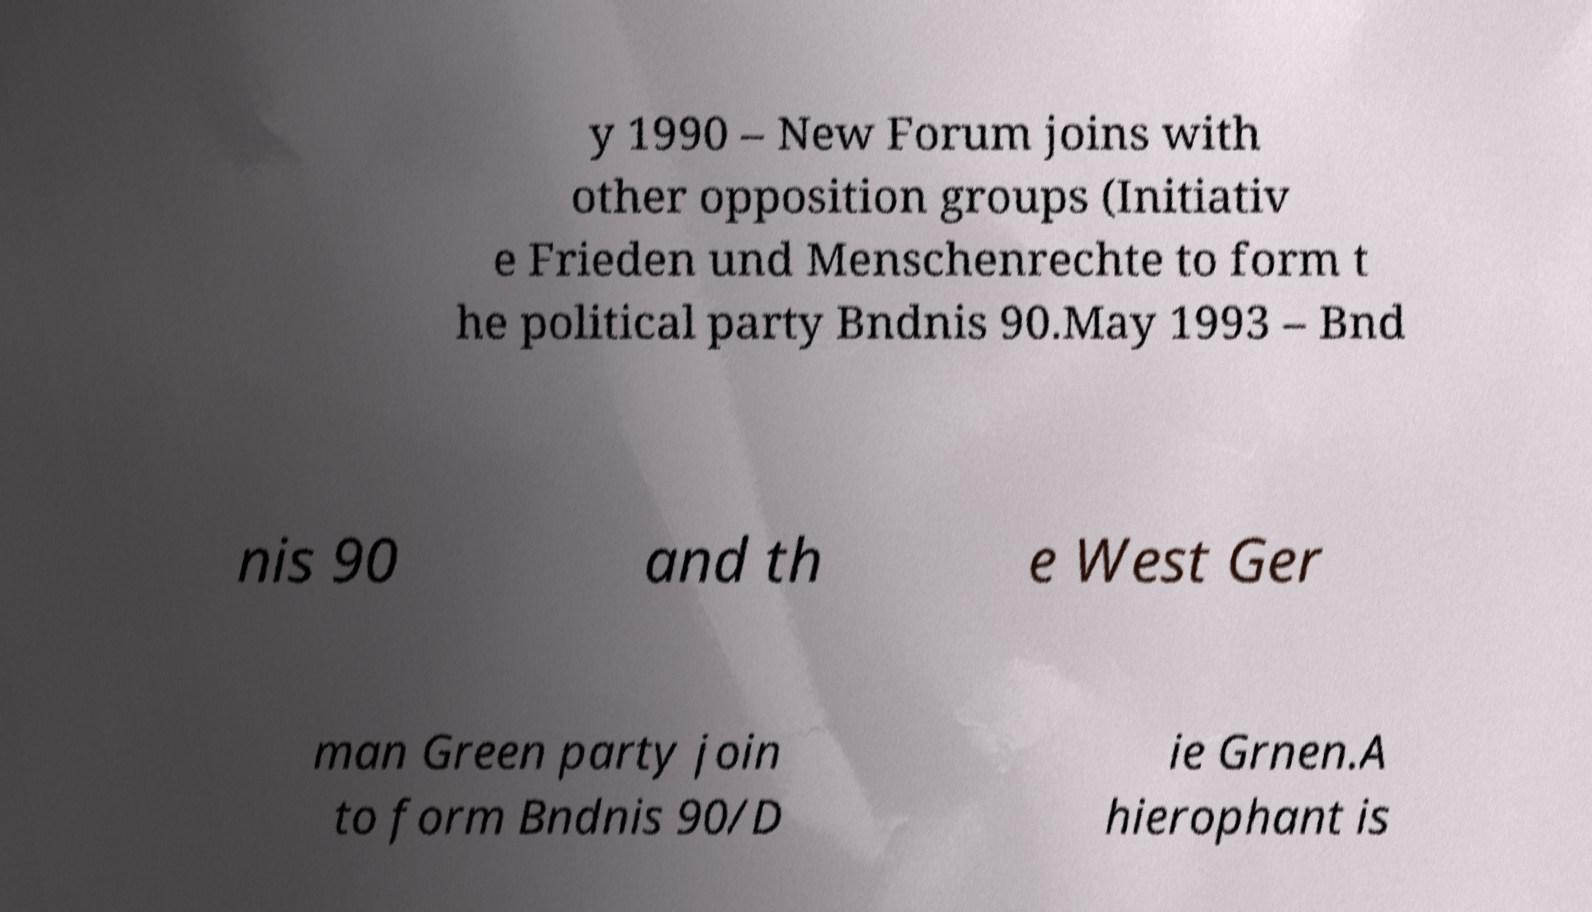There's text embedded in this image that I need extracted. Can you transcribe it verbatim? y 1990 – New Forum joins with other opposition groups (Initiativ e Frieden und Menschenrechte to form t he political party Bndnis 90.May 1993 – Bnd nis 90 and th e West Ger man Green party join to form Bndnis 90/D ie Grnen.A hierophant is 